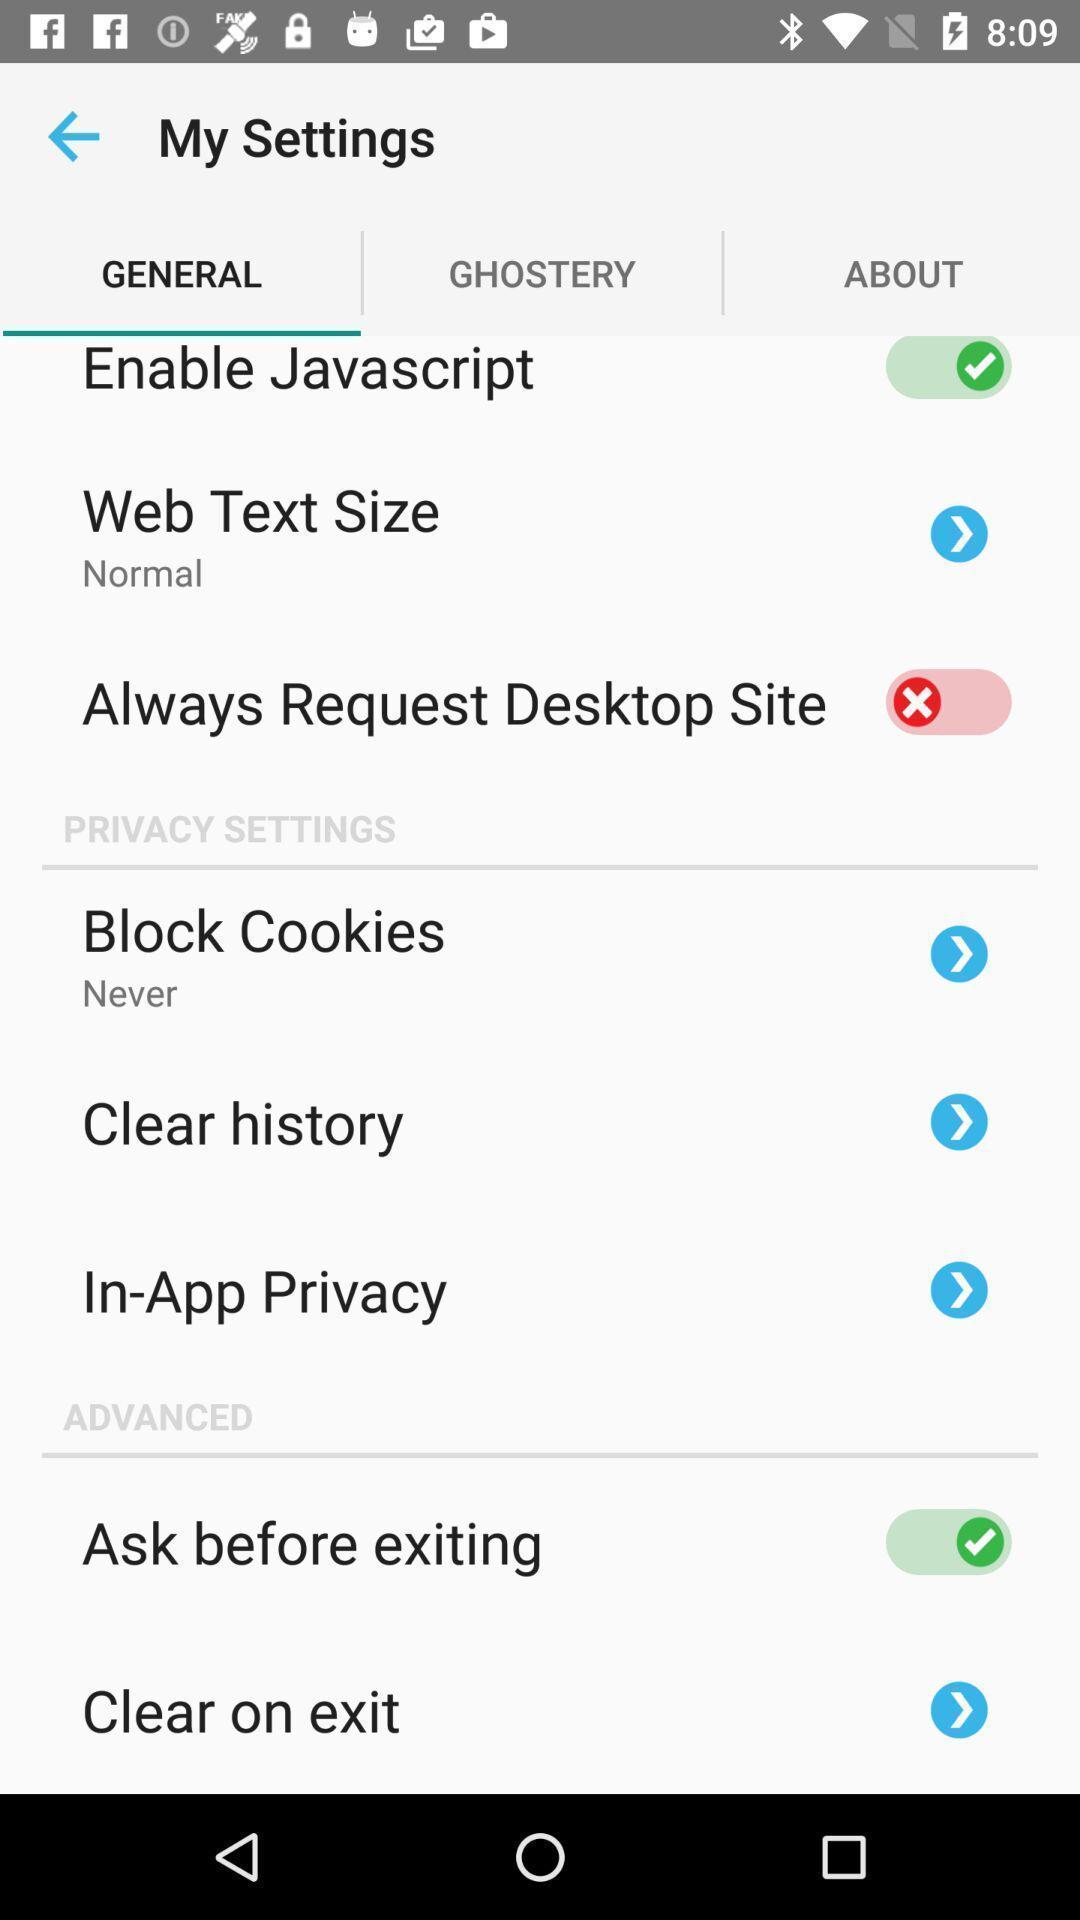What is the overall content of this screenshot? Screen shows general settings on a device. 